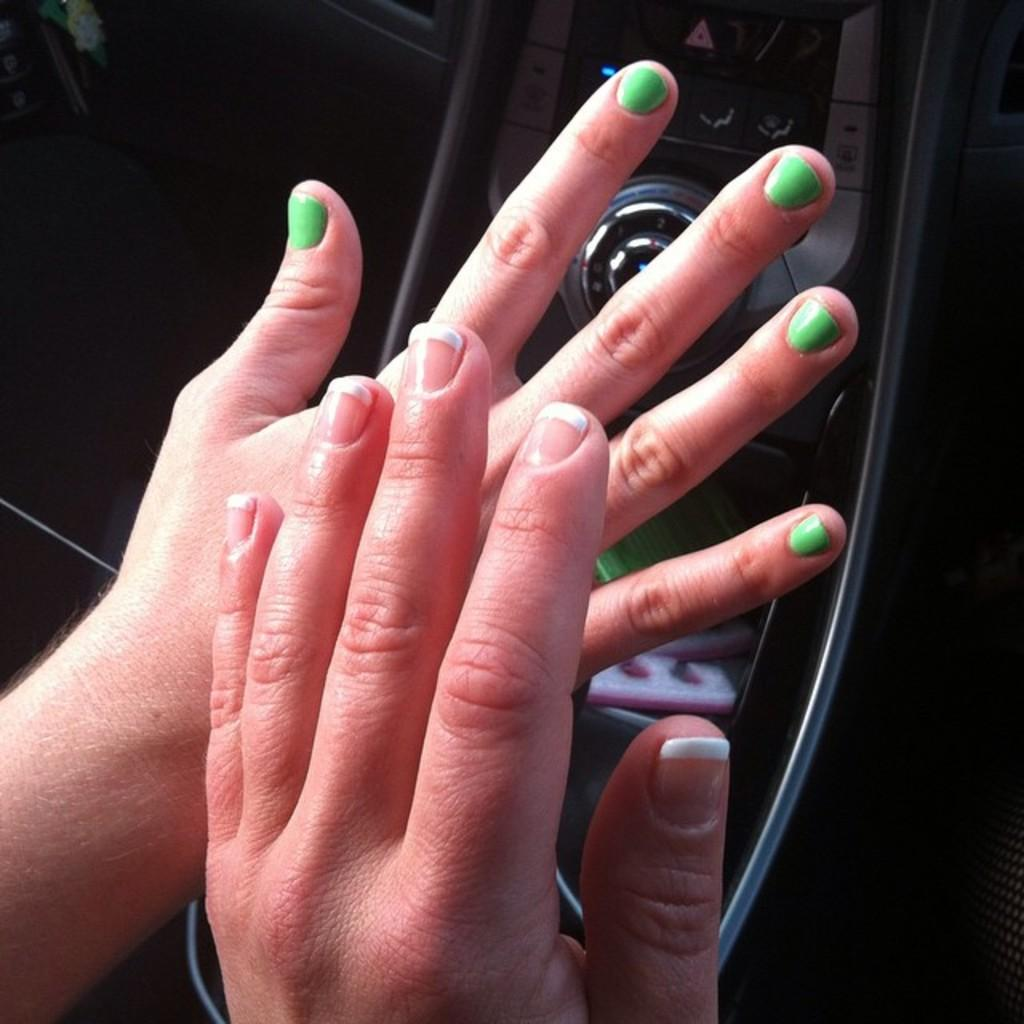What can be seen in the image? There are two hands in the image. What is the context of the image? There is a dashboard in the background of the image. What type of face is being offered by the needle in the image? There is no face or needle present in the image; it only features two hands and a dashboard. 